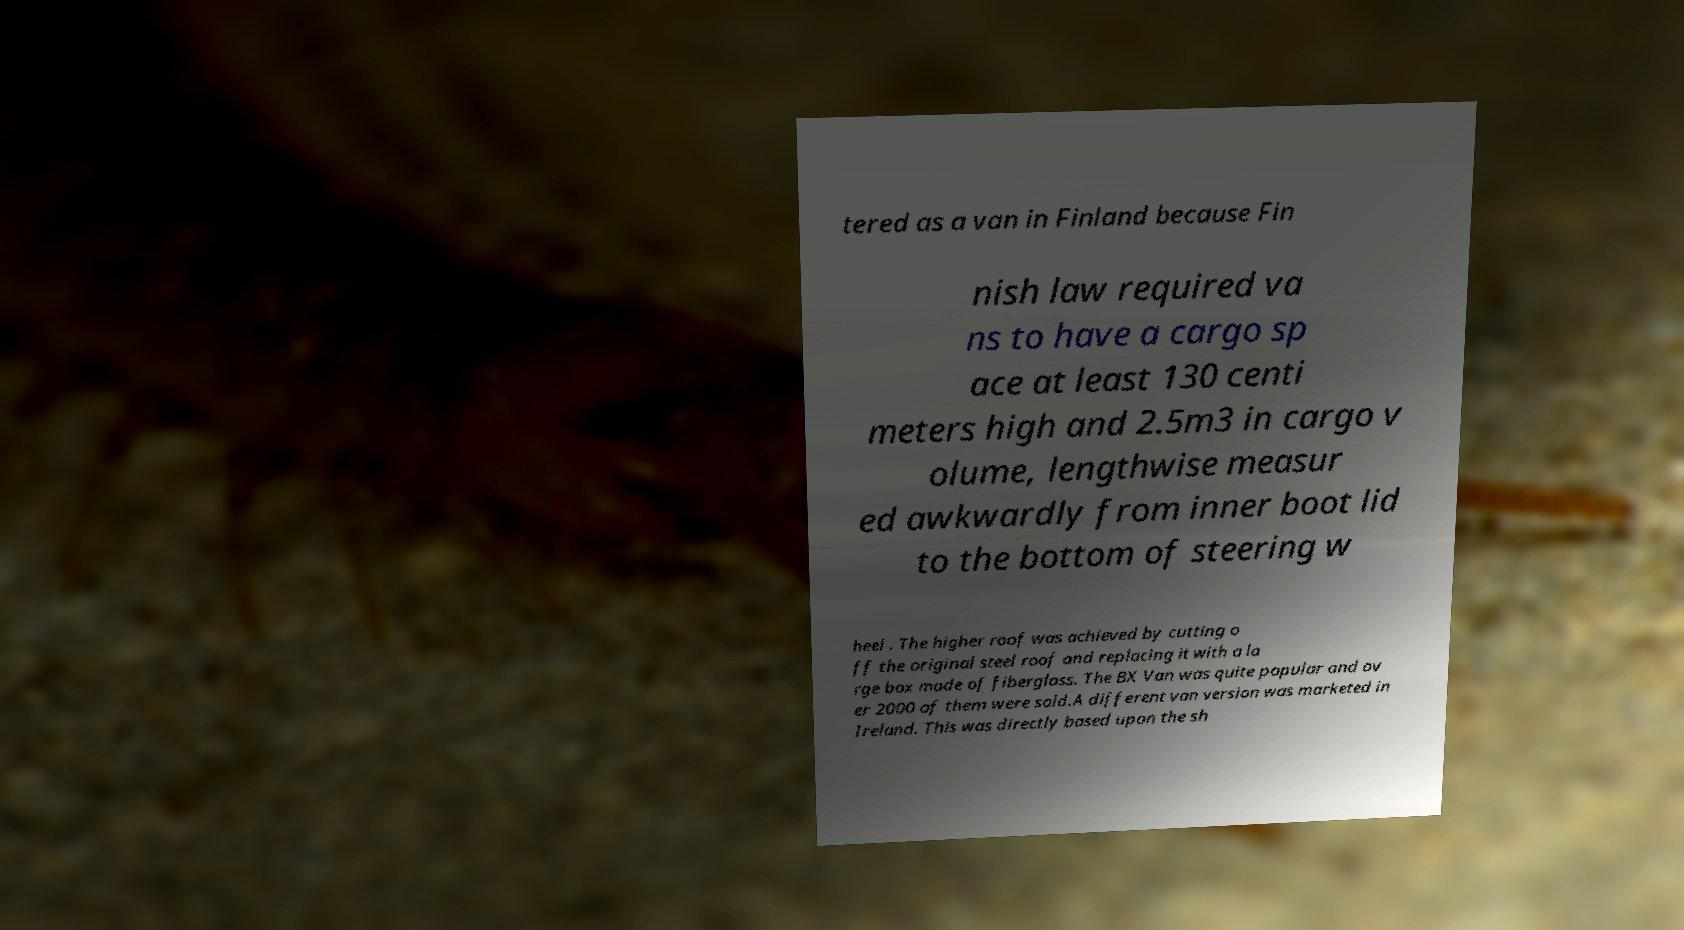Please read and relay the text visible in this image. What does it say? tered as a van in Finland because Fin nish law required va ns to have a cargo sp ace at least 130 centi meters high and 2.5m3 in cargo v olume, lengthwise measur ed awkwardly from inner boot lid to the bottom of steering w heel . The higher roof was achieved by cutting o ff the original steel roof and replacing it with a la rge box made of fiberglass. The BX Van was quite popular and ov er 2000 of them were sold.A different van version was marketed in Ireland. This was directly based upon the sh 